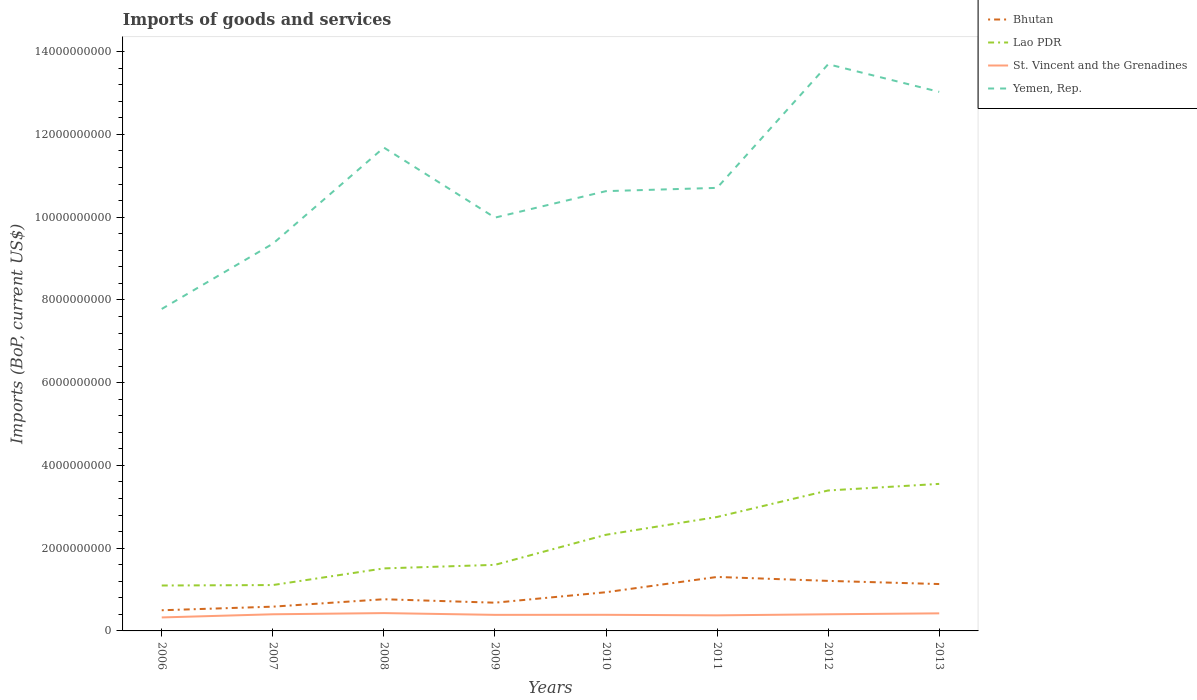How many different coloured lines are there?
Provide a short and direct response. 4. Does the line corresponding to Bhutan intersect with the line corresponding to Lao PDR?
Your response must be concise. No. Is the number of lines equal to the number of legend labels?
Your answer should be very brief. Yes. Across all years, what is the maximum amount spent on imports in St. Vincent and the Grenadines?
Give a very brief answer. 3.26e+08. In which year was the amount spent on imports in Lao PDR maximum?
Provide a succinct answer. 2006. What is the total amount spent on imports in Yemen, Rep. in the graph?
Your response must be concise. -2.01e+09. What is the difference between the highest and the second highest amount spent on imports in Yemen, Rep.?
Provide a short and direct response. 5.91e+09. What is the difference between the highest and the lowest amount spent on imports in Bhutan?
Make the answer very short. 4. Is the amount spent on imports in Bhutan strictly greater than the amount spent on imports in Yemen, Rep. over the years?
Your answer should be compact. Yes. How many lines are there?
Offer a very short reply. 4. Does the graph contain any zero values?
Make the answer very short. No. Where does the legend appear in the graph?
Your answer should be compact. Top right. How many legend labels are there?
Your answer should be compact. 4. What is the title of the graph?
Your answer should be very brief. Imports of goods and services. What is the label or title of the X-axis?
Provide a short and direct response. Years. What is the label or title of the Y-axis?
Provide a succinct answer. Imports (BoP, current US$). What is the Imports (BoP, current US$) in Bhutan in 2006?
Offer a very short reply. 4.99e+08. What is the Imports (BoP, current US$) in Lao PDR in 2006?
Keep it short and to the point. 1.10e+09. What is the Imports (BoP, current US$) in St. Vincent and the Grenadines in 2006?
Offer a terse response. 3.26e+08. What is the Imports (BoP, current US$) of Yemen, Rep. in 2006?
Give a very brief answer. 7.78e+09. What is the Imports (BoP, current US$) in Bhutan in 2007?
Your answer should be very brief. 5.86e+08. What is the Imports (BoP, current US$) in Lao PDR in 2007?
Provide a short and direct response. 1.11e+09. What is the Imports (BoP, current US$) of St. Vincent and the Grenadines in 2007?
Offer a terse response. 4.02e+08. What is the Imports (BoP, current US$) of Yemen, Rep. in 2007?
Provide a succinct answer. 9.36e+09. What is the Imports (BoP, current US$) in Bhutan in 2008?
Offer a terse response. 7.66e+08. What is the Imports (BoP, current US$) in Lao PDR in 2008?
Offer a terse response. 1.51e+09. What is the Imports (BoP, current US$) in St. Vincent and the Grenadines in 2008?
Your answer should be compact. 4.31e+08. What is the Imports (BoP, current US$) of Yemen, Rep. in 2008?
Keep it short and to the point. 1.17e+1. What is the Imports (BoP, current US$) of Bhutan in 2009?
Ensure brevity in your answer.  6.82e+08. What is the Imports (BoP, current US$) in Lao PDR in 2009?
Ensure brevity in your answer.  1.60e+09. What is the Imports (BoP, current US$) of St. Vincent and the Grenadines in 2009?
Make the answer very short. 3.88e+08. What is the Imports (BoP, current US$) in Yemen, Rep. in 2009?
Your answer should be compact. 9.99e+09. What is the Imports (BoP, current US$) in Bhutan in 2010?
Ensure brevity in your answer.  9.35e+08. What is the Imports (BoP, current US$) in Lao PDR in 2010?
Your answer should be very brief. 2.32e+09. What is the Imports (BoP, current US$) of St. Vincent and the Grenadines in 2010?
Your answer should be very brief. 3.89e+08. What is the Imports (BoP, current US$) in Yemen, Rep. in 2010?
Offer a terse response. 1.06e+1. What is the Imports (BoP, current US$) in Bhutan in 2011?
Your response must be concise. 1.30e+09. What is the Imports (BoP, current US$) in Lao PDR in 2011?
Provide a short and direct response. 2.75e+09. What is the Imports (BoP, current US$) of St. Vincent and the Grenadines in 2011?
Keep it short and to the point. 3.77e+08. What is the Imports (BoP, current US$) in Yemen, Rep. in 2011?
Your answer should be very brief. 1.07e+1. What is the Imports (BoP, current US$) of Bhutan in 2012?
Give a very brief answer. 1.21e+09. What is the Imports (BoP, current US$) in Lao PDR in 2012?
Offer a very short reply. 3.39e+09. What is the Imports (BoP, current US$) in St. Vincent and the Grenadines in 2012?
Ensure brevity in your answer.  4.02e+08. What is the Imports (BoP, current US$) of Yemen, Rep. in 2012?
Your answer should be very brief. 1.37e+1. What is the Imports (BoP, current US$) in Bhutan in 2013?
Provide a short and direct response. 1.13e+09. What is the Imports (BoP, current US$) of Lao PDR in 2013?
Keep it short and to the point. 3.55e+09. What is the Imports (BoP, current US$) in St. Vincent and the Grenadines in 2013?
Your answer should be very brief. 4.25e+08. What is the Imports (BoP, current US$) of Yemen, Rep. in 2013?
Offer a very short reply. 1.30e+1. Across all years, what is the maximum Imports (BoP, current US$) of Bhutan?
Keep it short and to the point. 1.30e+09. Across all years, what is the maximum Imports (BoP, current US$) of Lao PDR?
Ensure brevity in your answer.  3.55e+09. Across all years, what is the maximum Imports (BoP, current US$) of St. Vincent and the Grenadines?
Ensure brevity in your answer.  4.31e+08. Across all years, what is the maximum Imports (BoP, current US$) in Yemen, Rep.?
Your answer should be very brief. 1.37e+1. Across all years, what is the minimum Imports (BoP, current US$) of Bhutan?
Offer a very short reply. 4.99e+08. Across all years, what is the minimum Imports (BoP, current US$) of Lao PDR?
Make the answer very short. 1.10e+09. Across all years, what is the minimum Imports (BoP, current US$) of St. Vincent and the Grenadines?
Provide a succinct answer. 3.26e+08. Across all years, what is the minimum Imports (BoP, current US$) of Yemen, Rep.?
Make the answer very short. 7.78e+09. What is the total Imports (BoP, current US$) in Bhutan in the graph?
Your answer should be very brief. 7.12e+09. What is the total Imports (BoP, current US$) in Lao PDR in the graph?
Offer a terse response. 1.73e+1. What is the total Imports (BoP, current US$) of St. Vincent and the Grenadines in the graph?
Your response must be concise. 3.14e+09. What is the total Imports (BoP, current US$) of Yemen, Rep. in the graph?
Provide a succinct answer. 8.69e+1. What is the difference between the Imports (BoP, current US$) in Bhutan in 2006 and that in 2007?
Your response must be concise. -8.69e+07. What is the difference between the Imports (BoP, current US$) in Lao PDR in 2006 and that in 2007?
Your answer should be very brief. -1.08e+07. What is the difference between the Imports (BoP, current US$) of St. Vincent and the Grenadines in 2006 and that in 2007?
Make the answer very short. -7.63e+07. What is the difference between the Imports (BoP, current US$) of Yemen, Rep. in 2006 and that in 2007?
Your response must be concise. -1.58e+09. What is the difference between the Imports (BoP, current US$) of Bhutan in 2006 and that in 2008?
Ensure brevity in your answer.  -2.66e+08. What is the difference between the Imports (BoP, current US$) in Lao PDR in 2006 and that in 2008?
Your answer should be very brief. -4.13e+08. What is the difference between the Imports (BoP, current US$) of St. Vincent and the Grenadines in 2006 and that in 2008?
Keep it short and to the point. -1.05e+08. What is the difference between the Imports (BoP, current US$) in Yemen, Rep. in 2006 and that in 2008?
Keep it short and to the point. -3.90e+09. What is the difference between the Imports (BoP, current US$) of Bhutan in 2006 and that in 2009?
Ensure brevity in your answer.  -1.83e+08. What is the difference between the Imports (BoP, current US$) in Lao PDR in 2006 and that in 2009?
Provide a short and direct response. -4.99e+08. What is the difference between the Imports (BoP, current US$) in St. Vincent and the Grenadines in 2006 and that in 2009?
Make the answer very short. -6.22e+07. What is the difference between the Imports (BoP, current US$) in Yemen, Rep. in 2006 and that in 2009?
Provide a succinct answer. -2.21e+09. What is the difference between the Imports (BoP, current US$) of Bhutan in 2006 and that in 2010?
Your answer should be compact. -4.36e+08. What is the difference between the Imports (BoP, current US$) in Lao PDR in 2006 and that in 2010?
Provide a short and direct response. -1.23e+09. What is the difference between the Imports (BoP, current US$) in St. Vincent and the Grenadines in 2006 and that in 2010?
Provide a succinct answer. -6.33e+07. What is the difference between the Imports (BoP, current US$) in Yemen, Rep. in 2006 and that in 2010?
Provide a succinct answer. -2.85e+09. What is the difference between the Imports (BoP, current US$) of Bhutan in 2006 and that in 2011?
Offer a very short reply. -8.05e+08. What is the difference between the Imports (BoP, current US$) of Lao PDR in 2006 and that in 2011?
Provide a short and direct response. -1.66e+09. What is the difference between the Imports (BoP, current US$) of St. Vincent and the Grenadines in 2006 and that in 2011?
Your answer should be very brief. -5.08e+07. What is the difference between the Imports (BoP, current US$) in Yemen, Rep. in 2006 and that in 2011?
Your answer should be very brief. -2.93e+09. What is the difference between the Imports (BoP, current US$) in Bhutan in 2006 and that in 2012?
Keep it short and to the point. -7.10e+08. What is the difference between the Imports (BoP, current US$) in Lao PDR in 2006 and that in 2012?
Your answer should be compact. -2.30e+09. What is the difference between the Imports (BoP, current US$) of St. Vincent and the Grenadines in 2006 and that in 2012?
Ensure brevity in your answer.  -7.62e+07. What is the difference between the Imports (BoP, current US$) of Yemen, Rep. in 2006 and that in 2012?
Offer a very short reply. -5.91e+09. What is the difference between the Imports (BoP, current US$) in Bhutan in 2006 and that in 2013?
Your answer should be compact. -6.34e+08. What is the difference between the Imports (BoP, current US$) of Lao PDR in 2006 and that in 2013?
Your answer should be very brief. -2.46e+09. What is the difference between the Imports (BoP, current US$) in St. Vincent and the Grenadines in 2006 and that in 2013?
Your answer should be compact. -9.90e+07. What is the difference between the Imports (BoP, current US$) in Yemen, Rep. in 2006 and that in 2013?
Provide a succinct answer. -5.25e+09. What is the difference between the Imports (BoP, current US$) of Bhutan in 2007 and that in 2008?
Make the answer very short. -1.79e+08. What is the difference between the Imports (BoP, current US$) of Lao PDR in 2007 and that in 2008?
Your answer should be compact. -4.03e+08. What is the difference between the Imports (BoP, current US$) in St. Vincent and the Grenadines in 2007 and that in 2008?
Make the answer very short. -2.87e+07. What is the difference between the Imports (BoP, current US$) of Yemen, Rep. in 2007 and that in 2008?
Offer a very short reply. -2.32e+09. What is the difference between the Imports (BoP, current US$) in Bhutan in 2007 and that in 2009?
Give a very brief answer. -9.58e+07. What is the difference between the Imports (BoP, current US$) in Lao PDR in 2007 and that in 2009?
Offer a very short reply. -4.88e+08. What is the difference between the Imports (BoP, current US$) of St. Vincent and the Grenadines in 2007 and that in 2009?
Your answer should be very brief. 1.41e+07. What is the difference between the Imports (BoP, current US$) in Yemen, Rep. in 2007 and that in 2009?
Give a very brief answer. -6.31e+08. What is the difference between the Imports (BoP, current US$) in Bhutan in 2007 and that in 2010?
Your answer should be very brief. -3.49e+08. What is the difference between the Imports (BoP, current US$) in Lao PDR in 2007 and that in 2010?
Keep it short and to the point. -1.22e+09. What is the difference between the Imports (BoP, current US$) in St. Vincent and the Grenadines in 2007 and that in 2010?
Keep it short and to the point. 1.29e+07. What is the difference between the Imports (BoP, current US$) in Yemen, Rep. in 2007 and that in 2010?
Your answer should be compact. -1.27e+09. What is the difference between the Imports (BoP, current US$) in Bhutan in 2007 and that in 2011?
Make the answer very short. -7.18e+08. What is the difference between the Imports (BoP, current US$) of Lao PDR in 2007 and that in 2011?
Ensure brevity in your answer.  -1.65e+09. What is the difference between the Imports (BoP, current US$) in St. Vincent and the Grenadines in 2007 and that in 2011?
Your response must be concise. 2.55e+07. What is the difference between the Imports (BoP, current US$) of Yemen, Rep. in 2007 and that in 2011?
Ensure brevity in your answer.  -1.35e+09. What is the difference between the Imports (BoP, current US$) in Bhutan in 2007 and that in 2012?
Your response must be concise. -6.23e+08. What is the difference between the Imports (BoP, current US$) of Lao PDR in 2007 and that in 2012?
Give a very brief answer. -2.29e+09. What is the difference between the Imports (BoP, current US$) of St. Vincent and the Grenadines in 2007 and that in 2012?
Your answer should be compact. 1.83e+04. What is the difference between the Imports (BoP, current US$) in Yemen, Rep. in 2007 and that in 2012?
Offer a terse response. -4.34e+09. What is the difference between the Imports (BoP, current US$) of Bhutan in 2007 and that in 2013?
Offer a very short reply. -5.47e+08. What is the difference between the Imports (BoP, current US$) of Lao PDR in 2007 and that in 2013?
Provide a short and direct response. -2.44e+09. What is the difference between the Imports (BoP, current US$) in St. Vincent and the Grenadines in 2007 and that in 2013?
Keep it short and to the point. -2.27e+07. What is the difference between the Imports (BoP, current US$) of Yemen, Rep. in 2007 and that in 2013?
Keep it short and to the point. -3.67e+09. What is the difference between the Imports (BoP, current US$) in Bhutan in 2008 and that in 2009?
Provide a short and direct response. 8.35e+07. What is the difference between the Imports (BoP, current US$) of Lao PDR in 2008 and that in 2009?
Offer a very short reply. -8.56e+07. What is the difference between the Imports (BoP, current US$) in St. Vincent and the Grenadines in 2008 and that in 2009?
Provide a short and direct response. 4.28e+07. What is the difference between the Imports (BoP, current US$) of Yemen, Rep. in 2008 and that in 2009?
Provide a succinct answer. 1.69e+09. What is the difference between the Imports (BoP, current US$) of Bhutan in 2008 and that in 2010?
Give a very brief answer. -1.70e+08. What is the difference between the Imports (BoP, current US$) of Lao PDR in 2008 and that in 2010?
Your answer should be compact. -8.12e+08. What is the difference between the Imports (BoP, current US$) of St. Vincent and the Grenadines in 2008 and that in 2010?
Provide a succinct answer. 4.16e+07. What is the difference between the Imports (BoP, current US$) in Yemen, Rep. in 2008 and that in 2010?
Offer a terse response. 1.05e+09. What is the difference between the Imports (BoP, current US$) in Bhutan in 2008 and that in 2011?
Ensure brevity in your answer.  -5.39e+08. What is the difference between the Imports (BoP, current US$) in Lao PDR in 2008 and that in 2011?
Your answer should be compact. -1.24e+09. What is the difference between the Imports (BoP, current US$) in St. Vincent and the Grenadines in 2008 and that in 2011?
Your response must be concise. 5.42e+07. What is the difference between the Imports (BoP, current US$) of Yemen, Rep. in 2008 and that in 2011?
Give a very brief answer. 9.74e+08. What is the difference between the Imports (BoP, current US$) in Bhutan in 2008 and that in 2012?
Ensure brevity in your answer.  -4.44e+08. What is the difference between the Imports (BoP, current US$) in Lao PDR in 2008 and that in 2012?
Your answer should be very brief. -1.88e+09. What is the difference between the Imports (BoP, current US$) of St. Vincent and the Grenadines in 2008 and that in 2012?
Offer a very short reply. 2.87e+07. What is the difference between the Imports (BoP, current US$) in Yemen, Rep. in 2008 and that in 2012?
Your response must be concise. -2.01e+09. What is the difference between the Imports (BoP, current US$) in Bhutan in 2008 and that in 2013?
Provide a succinct answer. -3.67e+08. What is the difference between the Imports (BoP, current US$) in Lao PDR in 2008 and that in 2013?
Make the answer very short. -2.04e+09. What is the difference between the Imports (BoP, current US$) of St. Vincent and the Grenadines in 2008 and that in 2013?
Offer a very short reply. 6.00e+06. What is the difference between the Imports (BoP, current US$) of Yemen, Rep. in 2008 and that in 2013?
Provide a short and direct response. -1.35e+09. What is the difference between the Imports (BoP, current US$) of Bhutan in 2009 and that in 2010?
Your answer should be compact. -2.53e+08. What is the difference between the Imports (BoP, current US$) in Lao PDR in 2009 and that in 2010?
Provide a short and direct response. -7.27e+08. What is the difference between the Imports (BoP, current US$) of St. Vincent and the Grenadines in 2009 and that in 2010?
Give a very brief answer. -1.13e+06. What is the difference between the Imports (BoP, current US$) of Yemen, Rep. in 2009 and that in 2010?
Give a very brief answer. -6.41e+08. What is the difference between the Imports (BoP, current US$) of Bhutan in 2009 and that in 2011?
Give a very brief answer. -6.22e+08. What is the difference between the Imports (BoP, current US$) in Lao PDR in 2009 and that in 2011?
Your answer should be compact. -1.16e+09. What is the difference between the Imports (BoP, current US$) in St. Vincent and the Grenadines in 2009 and that in 2011?
Your answer should be very brief. 1.14e+07. What is the difference between the Imports (BoP, current US$) of Yemen, Rep. in 2009 and that in 2011?
Provide a short and direct response. -7.19e+08. What is the difference between the Imports (BoP, current US$) of Bhutan in 2009 and that in 2012?
Your answer should be compact. -5.27e+08. What is the difference between the Imports (BoP, current US$) of Lao PDR in 2009 and that in 2012?
Make the answer very short. -1.80e+09. What is the difference between the Imports (BoP, current US$) in St. Vincent and the Grenadines in 2009 and that in 2012?
Your response must be concise. -1.41e+07. What is the difference between the Imports (BoP, current US$) in Yemen, Rep. in 2009 and that in 2012?
Your response must be concise. -3.71e+09. What is the difference between the Imports (BoP, current US$) in Bhutan in 2009 and that in 2013?
Make the answer very short. -4.51e+08. What is the difference between the Imports (BoP, current US$) of Lao PDR in 2009 and that in 2013?
Keep it short and to the point. -1.96e+09. What is the difference between the Imports (BoP, current US$) of St. Vincent and the Grenadines in 2009 and that in 2013?
Your response must be concise. -3.68e+07. What is the difference between the Imports (BoP, current US$) in Yemen, Rep. in 2009 and that in 2013?
Offer a very short reply. -3.04e+09. What is the difference between the Imports (BoP, current US$) in Bhutan in 2010 and that in 2011?
Offer a very short reply. -3.69e+08. What is the difference between the Imports (BoP, current US$) in Lao PDR in 2010 and that in 2011?
Give a very brief answer. -4.30e+08. What is the difference between the Imports (BoP, current US$) in St. Vincent and the Grenadines in 2010 and that in 2011?
Your answer should be compact. 1.26e+07. What is the difference between the Imports (BoP, current US$) in Yemen, Rep. in 2010 and that in 2011?
Your answer should be very brief. -7.88e+07. What is the difference between the Imports (BoP, current US$) of Bhutan in 2010 and that in 2012?
Provide a short and direct response. -2.74e+08. What is the difference between the Imports (BoP, current US$) of Lao PDR in 2010 and that in 2012?
Your response must be concise. -1.07e+09. What is the difference between the Imports (BoP, current US$) of St. Vincent and the Grenadines in 2010 and that in 2012?
Provide a short and direct response. -1.29e+07. What is the difference between the Imports (BoP, current US$) in Yemen, Rep. in 2010 and that in 2012?
Ensure brevity in your answer.  -3.07e+09. What is the difference between the Imports (BoP, current US$) in Bhutan in 2010 and that in 2013?
Your answer should be compact. -1.98e+08. What is the difference between the Imports (BoP, current US$) of Lao PDR in 2010 and that in 2013?
Offer a very short reply. -1.23e+09. What is the difference between the Imports (BoP, current US$) of St. Vincent and the Grenadines in 2010 and that in 2013?
Make the answer very short. -3.56e+07. What is the difference between the Imports (BoP, current US$) in Yemen, Rep. in 2010 and that in 2013?
Your answer should be very brief. -2.40e+09. What is the difference between the Imports (BoP, current US$) of Bhutan in 2011 and that in 2012?
Give a very brief answer. 9.52e+07. What is the difference between the Imports (BoP, current US$) in Lao PDR in 2011 and that in 2012?
Keep it short and to the point. -6.41e+08. What is the difference between the Imports (BoP, current US$) in St. Vincent and the Grenadines in 2011 and that in 2012?
Provide a short and direct response. -2.55e+07. What is the difference between the Imports (BoP, current US$) in Yemen, Rep. in 2011 and that in 2012?
Provide a succinct answer. -2.99e+09. What is the difference between the Imports (BoP, current US$) in Bhutan in 2011 and that in 2013?
Make the answer very short. 1.72e+08. What is the difference between the Imports (BoP, current US$) in Lao PDR in 2011 and that in 2013?
Keep it short and to the point. -8.00e+08. What is the difference between the Imports (BoP, current US$) of St. Vincent and the Grenadines in 2011 and that in 2013?
Your answer should be very brief. -4.82e+07. What is the difference between the Imports (BoP, current US$) of Yemen, Rep. in 2011 and that in 2013?
Offer a very short reply. -2.32e+09. What is the difference between the Imports (BoP, current US$) in Bhutan in 2012 and that in 2013?
Ensure brevity in your answer.  7.64e+07. What is the difference between the Imports (BoP, current US$) in Lao PDR in 2012 and that in 2013?
Give a very brief answer. -1.59e+08. What is the difference between the Imports (BoP, current US$) of St. Vincent and the Grenadines in 2012 and that in 2013?
Keep it short and to the point. -2.27e+07. What is the difference between the Imports (BoP, current US$) in Yemen, Rep. in 2012 and that in 2013?
Keep it short and to the point. 6.68e+08. What is the difference between the Imports (BoP, current US$) in Bhutan in 2006 and the Imports (BoP, current US$) in Lao PDR in 2007?
Ensure brevity in your answer.  -6.09e+08. What is the difference between the Imports (BoP, current US$) of Bhutan in 2006 and the Imports (BoP, current US$) of St. Vincent and the Grenadines in 2007?
Offer a very short reply. 9.73e+07. What is the difference between the Imports (BoP, current US$) in Bhutan in 2006 and the Imports (BoP, current US$) in Yemen, Rep. in 2007?
Your response must be concise. -8.86e+09. What is the difference between the Imports (BoP, current US$) of Lao PDR in 2006 and the Imports (BoP, current US$) of St. Vincent and the Grenadines in 2007?
Offer a terse response. 6.96e+08. What is the difference between the Imports (BoP, current US$) of Lao PDR in 2006 and the Imports (BoP, current US$) of Yemen, Rep. in 2007?
Make the answer very short. -8.26e+09. What is the difference between the Imports (BoP, current US$) in St. Vincent and the Grenadines in 2006 and the Imports (BoP, current US$) in Yemen, Rep. in 2007?
Offer a very short reply. -9.03e+09. What is the difference between the Imports (BoP, current US$) of Bhutan in 2006 and the Imports (BoP, current US$) of Lao PDR in 2008?
Make the answer very short. -1.01e+09. What is the difference between the Imports (BoP, current US$) in Bhutan in 2006 and the Imports (BoP, current US$) in St. Vincent and the Grenadines in 2008?
Give a very brief answer. 6.86e+07. What is the difference between the Imports (BoP, current US$) of Bhutan in 2006 and the Imports (BoP, current US$) of Yemen, Rep. in 2008?
Keep it short and to the point. -1.12e+1. What is the difference between the Imports (BoP, current US$) in Lao PDR in 2006 and the Imports (BoP, current US$) in St. Vincent and the Grenadines in 2008?
Offer a very short reply. 6.67e+08. What is the difference between the Imports (BoP, current US$) of Lao PDR in 2006 and the Imports (BoP, current US$) of Yemen, Rep. in 2008?
Provide a succinct answer. -1.06e+1. What is the difference between the Imports (BoP, current US$) in St. Vincent and the Grenadines in 2006 and the Imports (BoP, current US$) in Yemen, Rep. in 2008?
Offer a terse response. -1.14e+1. What is the difference between the Imports (BoP, current US$) of Bhutan in 2006 and the Imports (BoP, current US$) of Lao PDR in 2009?
Provide a succinct answer. -1.10e+09. What is the difference between the Imports (BoP, current US$) of Bhutan in 2006 and the Imports (BoP, current US$) of St. Vincent and the Grenadines in 2009?
Your response must be concise. 1.11e+08. What is the difference between the Imports (BoP, current US$) in Bhutan in 2006 and the Imports (BoP, current US$) in Yemen, Rep. in 2009?
Keep it short and to the point. -9.49e+09. What is the difference between the Imports (BoP, current US$) of Lao PDR in 2006 and the Imports (BoP, current US$) of St. Vincent and the Grenadines in 2009?
Offer a very short reply. 7.10e+08. What is the difference between the Imports (BoP, current US$) in Lao PDR in 2006 and the Imports (BoP, current US$) in Yemen, Rep. in 2009?
Provide a succinct answer. -8.89e+09. What is the difference between the Imports (BoP, current US$) in St. Vincent and the Grenadines in 2006 and the Imports (BoP, current US$) in Yemen, Rep. in 2009?
Make the answer very short. -9.66e+09. What is the difference between the Imports (BoP, current US$) in Bhutan in 2006 and the Imports (BoP, current US$) in Lao PDR in 2010?
Make the answer very short. -1.82e+09. What is the difference between the Imports (BoP, current US$) of Bhutan in 2006 and the Imports (BoP, current US$) of St. Vincent and the Grenadines in 2010?
Ensure brevity in your answer.  1.10e+08. What is the difference between the Imports (BoP, current US$) in Bhutan in 2006 and the Imports (BoP, current US$) in Yemen, Rep. in 2010?
Make the answer very short. -1.01e+1. What is the difference between the Imports (BoP, current US$) in Lao PDR in 2006 and the Imports (BoP, current US$) in St. Vincent and the Grenadines in 2010?
Give a very brief answer. 7.08e+08. What is the difference between the Imports (BoP, current US$) of Lao PDR in 2006 and the Imports (BoP, current US$) of Yemen, Rep. in 2010?
Ensure brevity in your answer.  -9.53e+09. What is the difference between the Imports (BoP, current US$) of St. Vincent and the Grenadines in 2006 and the Imports (BoP, current US$) of Yemen, Rep. in 2010?
Provide a succinct answer. -1.03e+1. What is the difference between the Imports (BoP, current US$) in Bhutan in 2006 and the Imports (BoP, current US$) in Lao PDR in 2011?
Offer a very short reply. -2.25e+09. What is the difference between the Imports (BoP, current US$) of Bhutan in 2006 and the Imports (BoP, current US$) of St. Vincent and the Grenadines in 2011?
Your answer should be compact. 1.23e+08. What is the difference between the Imports (BoP, current US$) of Bhutan in 2006 and the Imports (BoP, current US$) of Yemen, Rep. in 2011?
Offer a terse response. -1.02e+1. What is the difference between the Imports (BoP, current US$) in Lao PDR in 2006 and the Imports (BoP, current US$) in St. Vincent and the Grenadines in 2011?
Keep it short and to the point. 7.21e+08. What is the difference between the Imports (BoP, current US$) in Lao PDR in 2006 and the Imports (BoP, current US$) in Yemen, Rep. in 2011?
Ensure brevity in your answer.  -9.61e+09. What is the difference between the Imports (BoP, current US$) in St. Vincent and the Grenadines in 2006 and the Imports (BoP, current US$) in Yemen, Rep. in 2011?
Keep it short and to the point. -1.04e+1. What is the difference between the Imports (BoP, current US$) of Bhutan in 2006 and the Imports (BoP, current US$) of Lao PDR in 2012?
Make the answer very short. -2.89e+09. What is the difference between the Imports (BoP, current US$) of Bhutan in 2006 and the Imports (BoP, current US$) of St. Vincent and the Grenadines in 2012?
Give a very brief answer. 9.73e+07. What is the difference between the Imports (BoP, current US$) of Bhutan in 2006 and the Imports (BoP, current US$) of Yemen, Rep. in 2012?
Provide a succinct answer. -1.32e+1. What is the difference between the Imports (BoP, current US$) in Lao PDR in 2006 and the Imports (BoP, current US$) in St. Vincent and the Grenadines in 2012?
Offer a terse response. 6.96e+08. What is the difference between the Imports (BoP, current US$) of Lao PDR in 2006 and the Imports (BoP, current US$) of Yemen, Rep. in 2012?
Your response must be concise. -1.26e+1. What is the difference between the Imports (BoP, current US$) of St. Vincent and the Grenadines in 2006 and the Imports (BoP, current US$) of Yemen, Rep. in 2012?
Make the answer very short. -1.34e+1. What is the difference between the Imports (BoP, current US$) of Bhutan in 2006 and the Imports (BoP, current US$) of Lao PDR in 2013?
Your answer should be compact. -3.05e+09. What is the difference between the Imports (BoP, current US$) in Bhutan in 2006 and the Imports (BoP, current US$) in St. Vincent and the Grenadines in 2013?
Keep it short and to the point. 7.46e+07. What is the difference between the Imports (BoP, current US$) of Bhutan in 2006 and the Imports (BoP, current US$) of Yemen, Rep. in 2013?
Make the answer very short. -1.25e+1. What is the difference between the Imports (BoP, current US$) in Lao PDR in 2006 and the Imports (BoP, current US$) in St. Vincent and the Grenadines in 2013?
Keep it short and to the point. 6.73e+08. What is the difference between the Imports (BoP, current US$) of Lao PDR in 2006 and the Imports (BoP, current US$) of Yemen, Rep. in 2013?
Provide a succinct answer. -1.19e+1. What is the difference between the Imports (BoP, current US$) of St. Vincent and the Grenadines in 2006 and the Imports (BoP, current US$) of Yemen, Rep. in 2013?
Provide a succinct answer. -1.27e+1. What is the difference between the Imports (BoP, current US$) of Bhutan in 2007 and the Imports (BoP, current US$) of Lao PDR in 2008?
Provide a succinct answer. -9.25e+08. What is the difference between the Imports (BoP, current US$) in Bhutan in 2007 and the Imports (BoP, current US$) in St. Vincent and the Grenadines in 2008?
Offer a very short reply. 1.56e+08. What is the difference between the Imports (BoP, current US$) of Bhutan in 2007 and the Imports (BoP, current US$) of Yemen, Rep. in 2008?
Offer a very short reply. -1.11e+1. What is the difference between the Imports (BoP, current US$) in Lao PDR in 2007 and the Imports (BoP, current US$) in St. Vincent and the Grenadines in 2008?
Your response must be concise. 6.78e+08. What is the difference between the Imports (BoP, current US$) of Lao PDR in 2007 and the Imports (BoP, current US$) of Yemen, Rep. in 2008?
Provide a succinct answer. -1.06e+1. What is the difference between the Imports (BoP, current US$) of St. Vincent and the Grenadines in 2007 and the Imports (BoP, current US$) of Yemen, Rep. in 2008?
Your answer should be compact. -1.13e+1. What is the difference between the Imports (BoP, current US$) in Bhutan in 2007 and the Imports (BoP, current US$) in Lao PDR in 2009?
Your response must be concise. -1.01e+09. What is the difference between the Imports (BoP, current US$) in Bhutan in 2007 and the Imports (BoP, current US$) in St. Vincent and the Grenadines in 2009?
Offer a terse response. 1.98e+08. What is the difference between the Imports (BoP, current US$) of Bhutan in 2007 and the Imports (BoP, current US$) of Yemen, Rep. in 2009?
Make the answer very short. -9.40e+09. What is the difference between the Imports (BoP, current US$) of Lao PDR in 2007 and the Imports (BoP, current US$) of St. Vincent and the Grenadines in 2009?
Offer a terse response. 7.20e+08. What is the difference between the Imports (BoP, current US$) of Lao PDR in 2007 and the Imports (BoP, current US$) of Yemen, Rep. in 2009?
Your answer should be compact. -8.88e+09. What is the difference between the Imports (BoP, current US$) of St. Vincent and the Grenadines in 2007 and the Imports (BoP, current US$) of Yemen, Rep. in 2009?
Provide a succinct answer. -9.59e+09. What is the difference between the Imports (BoP, current US$) of Bhutan in 2007 and the Imports (BoP, current US$) of Lao PDR in 2010?
Provide a short and direct response. -1.74e+09. What is the difference between the Imports (BoP, current US$) in Bhutan in 2007 and the Imports (BoP, current US$) in St. Vincent and the Grenadines in 2010?
Ensure brevity in your answer.  1.97e+08. What is the difference between the Imports (BoP, current US$) of Bhutan in 2007 and the Imports (BoP, current US$) of Yemen, Rep. in 2010?
Offer a very short reply. -1.00e+1. What is the difference between the Imports (BoP, current US$) in Lao PDR in 2007 and the Imports (BoP, current US$) in St. Vincent and the Grenadines in 2010?
Ensure brevity in your answer.  7.19e+08. What is the difference between the Imports (BoP, current US$) of Lao PDR in 2007 and the Imports (BoP, current US$) of Yemen, Rep. in 2010?
Your answer should be very brief. -9.52e+09. What is the difference between the Imports (BoP, current US$) in St. Vincent and the Grenadines in 2007 and the Imports (BoP, current US$) in Yemen, Rep. in 2010?
Your answer should be very brief. -1.02e+1. What is the difference between the Imports (BoP, current US$) of Bhutan in 2007 and the Imports (BoP, current US$) of Lao PDR in 2011?
Provide a succinct answer. -2.17e+09. What is the difference between the Imports (BoP, current US$) in Bhutan in 2007 and the Imports (BoP, current US$) in St. Vincent and the Grenadines in 2011?
Your answer should be compact. 2.10e+08. What is the difference between the Imports (BoP, current US$) of Bhutan in 2007 and the Imports (BoP, current US$) of Yemen, Rep. in 2011?
Your answer should be compact. -1.01e+1. What is the difference between the Imports (BoP, current US$) of Lao PDR in 2007 and the Imports (BoP, current US$) of St. Vincent and the Grenadines in 2011?
Provide a short and direct response. 7.32e+08. What is the difference between the Imports (BoP, current US$) of Lao PDR in 2007 and the Imports (BoP, current US$) of Yemen, Rep. in 2011?
Ensure brevity in your answer.  -9.60e+09. What is the difference between the Imports (BoP, current US$) of St. Vincent and the Grenadines in 2007 and the Imports (BoP, current US$) of Yemen, Rep. in 2011?
Keep it short and to the point. -1.03e+1. What is the difference between the Imports (BoP, current US$) in Bhutan in 2007 and the Imports (BoP, current US$) in Lao PDR in 2012?
Offer a terse response. -2.81e+09. What is the difference between the Imports (BoP, current US$) in Bhutan in 2007 and the Imports (BoP, current US$) in St. Vincent and the Grenadines in 2012?
Make the answer very short. 1.84e+08. What is the difference between the Imports (BoP, current US$) of Bhutan in 2007 and the Imports (BoP, current US$) of Yemen, Rep. in 2012?
Give a very brief answer. -1.31e+1. What is the difference between the Imports (BoP, current US$) of Lao PDR in 2007 and the Imports (BoP, current US$) of St. Vincent and the Grenadines in 2012?
Offer a very short reply. 7.06e+08. What is the difference between the Imports (BoP, current US$) of Lao PDR in 2007 and the Imports (BoP, current US$) of Yemen, Rep. in 2012?
Your answer should be compact. -1.26e+1. What is the difference between the Imports (BoP, current US$) of St. Vincent and the Grenadines in 2007 and the Imports (BoP, current US$) of Yemen, Rep. in 2012?
Offer a terse response. -1.33e+1. What is the difference between the Imports (BoP, current US$) in Bhutan in 2007 and the Imports (BoP, current US$) in Lao PDR in 2013?
Your response must be concise. -2.97e+09. What is the difference between the Imports (BoP, current US$) of Bhutan in 2007 and the Imports (BoP, current US$) of St. Vincent and the Grenadines in 2013?
Ensure brevity in your answer.  1.62e+08. What is the difference between the Imports (BoP, current US$) in Bhutan in 2007 and the Imports (BoP, current US$) in Yemen, Rep. in 2013?
Give a very brief answer. -1.24e+1. What is the difference between the Imports (BoP, current US$) of Lao PDR in 2007 and the Imports (BoP, current US$) of St. Vincent and the Grenadines in 2013?
Provide a short and direct response. 6.84e+08. What is the difference between the Imports (BoP, current US$) of Lao PDR in 2007 and the Imports (BoP, current US$) of Yemen, Rep. in 2013?
Offer a terse response. -1.19e+1. What is the difference between the Imports (BoP, current US$) in St. Vincent and the Grenadines in 2007 and the Imports (BoP, current US$) in Yemen, Rep. in 2013?
Ensure brevity in your answer.  -1.26e+1. What is the difference between the Imports (BoP, current US$) of Bhutan in 2008 and the Imports (BoP, current US$) of Lao PDR in 2009?
Provide a succinct answer. -8.31e+08. What is the difference between the Imports (BoP, current US$) of Bhutan in 2008 and the Imports (BoP, current US$) of St. Vincent and the Grenadines in 2009?
Keep it short and to the point. 3.78e+08. What is the difference between the Imports (BoP, current US$) of Bhutan in 2008 and the Imports (BoP, current US$) of Yemen, Rep. in 2009?
Offer a very short reply. -9.22e+09. What is the difference between the Imports (BoP, current US$) in Lao PDR in 2008 and the Imports (BoP, current US$) in St. Vincent and the Grenadines in 2009?
Offer a very short reply. 1.12e+09. What is the difference between the Imports (BoP, current US$) in Lao PDR in 2008 and the Imports (BoP, current US$) in Yemen, Rep. in 2009?
Give a very brief answer. -8.48e+09. What is the difference between the Imports (BoP, current US$) in St. Vincent and the Grenadines in 2008 and the Imports (BoP, current US$) in Yemen, Rep. in 2009?
Offer a very short reply. -9.56e+09. What is the difference between the Imports (BoP, current US$) in Bhutan in 2008 and the Imports (BoP, current US$) in Lao PDR in 2010?
Offer a very short reply. -1.56e+09. What is the difference between the Imports (BoP, current US$) in Bhutan in 2008 and the Imports (BoP, current US$) in St. Vincent and the Grenadines in 2010?
Make the answer very short. 3.76e+08. What is the difference between the Imports (BoP, current US$) in Bhutan in 2008 and the Imports (BoP, current US$) in Yemen, Rep. in 2010?
Provide a short and direct response. -9.86e+09. What is the difference between the Imports (BoP, current US$) in Lao PDR in 2008 and the Imports (BoP, current US$) in St. Vincent and the Grenadines in 2010?
Your answer should be very brief. 1.12e+09. What is the difference between the Imports (BoP, current US$) in Lao PDR in 2008 and the Imports (BoP, current US$) in Yemen, Rep. in 2010?
Ensure brevity in your answer.  -9.12e+09. What is the difference between the Imports (BoP, current US$) of St. Vincent and the Grenadines in 2008 and the Imports (BoP, current US$) of Yemen, Rep. in 2010?
Your answer should be compact. -1.02e+1. What is the difference between the Imports (BoP, current US$) in Bhutan in 2008 and the Imports (BoP, current US$) in Lao PDR in 2011?
Your response must be concise. -1.99e+09. What is the difference between the Imports (BoP, current US$) in Bhutan in 2008 and the Imports (BoP, current US$) in St. Vincent and the Grenadines in 2011?
Keep it short and to the point. 3.89e+08. What is the difference between the Imports (BoP, current US$) in Bhutan in 2008 and the Imports (BoP, current US$) in Yemen, Rep. in 2011?
Offer a very short reply. -9.94e+09. What is the difference between the Imports (BoP, current US$) of Lao PDR in 2008 and the Imports (BoP, current US$) of St. Vincent and the Grenadines in 2011?
Your answer should be very brief. 1.13e+09. What is the difference between the Imports (BoP, current US$) of Lao PDR in 2008 and the Imports (BoP, current US$) of Yemen, Rep. in 2011?
Give a very brief answer. -9.20e+09. What is the difference between the Imports (BoP, current US$) in St. Vincent and the Grenadines in 2008 and the Imports (BoP, current US$) in Yemen, Rep. in 2011?
Keep it short and to the point. -1.03e+1. What is the difference between the Imports (BoP, current US$) in Bhutan in 2008 and the Imports (BoP, current US$) in Lao PDR in 2012?
Give a very brief answer. -2.63e+09. What is the difference between the Imports (BoP, current US$) in Bhutan in 2008 and the Imports (BoP, current US$) in St. Vincent and the Grenadines in 2012?
Provide a short and direct response. 3.64e+08. What is the difference between the Imports (BoP, current US$) in Bhutan in 2008 and the Imports (BoP, current US$) in Yemen, Rep. in 2012?
Make the answer very short. -1.29e+1. What is the difference between the Imports (BoP, current US$) in Lao PDR in 2008 and the Imports (BoP, current US$) in St. Vincent and the Grenadines in 2012?
Offer a very short reply. 1.11e+09. What is the difference between the Imports (BoP, current US$) in Lao PDR in 2008 and the Imports (BoP, current US$) in Yemen, Rep. in 2012?
Give a very brief answer. -1.22e+1. What is the difference between the Imports (BoP, current US$) of St. Vincent and the Grenadines in 2008 and the Imports (BoP, current US$) of Yemen, Rep. in 2012?
Give a very brief answer. -1.33e+1. What is the difference between the Imports (BoP, current US$) in Bhutan in 2008 and the Imports (BoP, current US$) in Lao PDR in 2013?
Give a very brief answer. -2.79e+09. What is the difference between the Imports (BoP, current US$) in Bhutan in 2008 and the Imports (BoP, current US$) in St. Vincent and the Grenadines in 2013?
Give a very brief answer. 3.41e+08. What is the difference between the Imports (BoP, current US$) in Bhutan in 2008 and the Imports (BoP, current US$) in Yemen, Rep. in 2013?
Keep it short and to the point. -1.23e+1. What is the difference between the Imports (BoP, current US$) of Lao PDR in 2008 and the Imports (BoP, current US$) of St. Vincent and the Grenadines in 2013?
Your response must be concise. 1.09e+09. What is the difference between the Imports (BoP, current US$) of Lao PDR in 2008 and the Imports (BoP, current US$) of Yemen, Rep. in 2013?
Offer a terse response. -1.15e+1. What is the difference between the Imports (BoP, current US$) of St. Vincent and the Grenadines in 2008 and the Imports (BoP, current US$) of Yemen, Rep. in 2013?
Provide a succinct answer. -1.26e+1. What is the difference between the Imports (BoP, current US$) of Bhutan in 2009 and the Imports (BoP, current US$) of Lao PDR in 2010?
Make the answer very short. -1.64e+09. What is the difference between the Imports (BoP, current US$) of Bhutan in 2009 and the Imports (BoP, current US$) of St. Vincent and the Grenadines in 2010?
Your answer should be very brief. 2.93e+08. What is the difference between the Imports (BoP, current US$) of Bhutan in 2009 and the Imports (BoP, current US$) of Yemen, Rep. in 2010?
Your response must be concise. -9.95e+09. What is the difference between the Imports (BoP, current US$) of Lao PDR in 2009 and the Imports (BoP, current US$) of St. Vincent and the Grenadines in 2010?
Offer a very short reply. 1.21e+09. What is the difference between the Imports (BoP, current US$) of Lao PDR in 2009 and the Imports (BoP, current US$) of Yemen, Rep. in 2010?
Provide a short and direct response. -9.03e+09. What is the difference between the Imports (BoP, current US$) of St. Vincent and the Grenadines in 2009 and the Imports (BoP, current US$) of Yemen, Rep. in 2010?
Give a very brief answer. -1.02e+1. What is the difference between the Imports (BoP, current US$) of Bhutan in 2009 and the Imports (BoP, current US$) of Lao PDR in 2011?
Provide a succinct answer. -2.07e+09. What is the difference between the Imports (BoP, current US$) of Bhutan in 2009 and the Imports (BoP, current US$) of St. Vincent and the Grenadines in 2011?
Provide a short and direct response. 3.06e+08. What is the difference between the Imports (BoP, current US$) in Bhutan in 2009 and the Imports (BoP, current US$) in Yemen, Rep. in 2011?
Provide a succinct answer. -1.00e+1. What is the difference between the Imports (BoP, current US$) in Lao PDR in 2009 and the Imports (BoP, current US$) in St. Vincent and the Grenadines in 2011?
Provide a short and direct response. 1.22e+09. What is the difference between the Imports (BoP, current US$) in Lao PDR in 2009 and the Imports (BoP, current US$) in Yemen, Rep. in 2011?
Offer a terse response. -9.11e+09. What is the difference between the Imports (BoP, current US$) of St. Vincent and the Grenadines in 2009 and the Imports (BoP, current US$) of Yemen, Rep. in 2011?
Provide a succinct answer. -1.03e+1. What is the difference between the Imports (BoP, current US$) of Bhutan in 2009 and the Imports (BoP, current US$) of Lao PDR in 2012?
Ensure brevity in your answer.  -2.71e+09. What is the difference between the Imports (BoP, current US$) of Bhutan in 2009 and the Imports (BoP, current US$) of St. Vincent and the Grenadines in 2012?
Offer a very short reply. 2.80e+08. What is the difference between the Imports (BoP, current US$) of Bhutan in 2009 and the Imports (BoP, current US$) of Yemen, Rep. in 2012?
Ensure brevity in your answer.  -1.30e+1. What is the difference between the Imports (BoP, current US$) in Lao PDR in 2009 and the Imports (BoP, current US$) in St. Vincent and the Grenadines in 2012?
Keep it short and to the point. 1.19e+09. What is the difference between the Imports (BoP, current US$) in Lao PDR in 2009 and the Imports (BoP, current US$) in Yemen, Rep. in 2012?
Ensure brevity in your answer.  -1.21e+1. What is the difference between the Imports (BoP, current US$) of St. Vincent and the Grenadines in 2009 and the Imports (BoP, current US$) of Yemen, Rep. in 2012?
Keep it short and to the point. -1.33e+1. What is the difference between the Imports (BoP, current US$) of Bhutan in 2009 and the Imports (BoP, current US$) of Lao PDR in 2013?
Offer a very short reply. -2.87e+09. What is the difference between the Imports (BoP, current US$) of Bhutan in 2009 and the Imports (BoP, current US$) of St. Vincent and the Grenadines in 2013?
Provide a succinct answer. 2.57e+08. What is the difference between the Imports (BoP, current US$) in Bhutan in 2009 and the Imports (BoP, current US$) in Yemen, Rep. in 2013?
Your response must be concise. -1.23e+1. What is the difference between the Imports (BoP, current US$) of Lao PDR in 2009 and the Imports (BoP, current US$) of St. Vincent and the Grenadines in 2013?
Your answer should be compact. 1.17e+09. What is the difference between the Imports (BoP, current US$) of Lao PDR in 2009 and the Imports (BoP, current US$) of Yemen, Rep. in 2013?
Your answer should be very brief. -1.14e+1. What is the difference between the Imports (BoP, current US$) in St. Vincent and the Grenadines in 2009 and the Imports (BoP, current US$) in Yemen, Rep. in 2013?
Offer a terse response. -1.26e+1. What is the difference between the Imports (BoP, current US$) of Bhutan in 2010 and the Imports (BoP, current US$) of Lao PDR in 2011?
Your answer should be very brief. -1.82e+09. What is the difference between the Imports (BoP, current US$) of Bhutan in 2010 and the Imports (BoP, current US$) of St. Vincent and the Grenadines in 2011?
Provide a succinct answer. 5.59e+08. What is the difference between the Imports (BoP, current US$) of Bhutan in 2010 and the Imports (BoP, current US$) of Yemen, Rep. in 2011?
Provide a short and direct response. -9.77e+09. What is the difference between the Imports (BoP, current US$) in Lao PDR in 2010 and the Imports (BoP, current US$) in St. Vincent and the Grenadines in 2011?
Your answer should be very brief. 1.95e+09. What is the difference between the Imports (BoP, current US$) of Lao PDR in 2010 and the Imports (BoP, current US$) of Yemen, Rep. in 2011?
Your response must be concise. -8.38e+09. What is the difference between the Imports (BoP, current US$) in St. Vincent and the Grenadines in 2010 and the Imports (BoP, current US$) in Yemen, Rep. in 2011?
Your answer should be compact. -1.03e+1. What is the difference between the Imports (BoP, current US$) of Bhutan in 2010 and the Imports (BoP, current US$) of Lao PDR in 2012?
Give a very brief answer. -2.46e+09. What is the difference between the Imports (BoP, current US$) in Bhutan in 2010 and the Imports (BoP, current US$) in St. Vincent and the Grenadines in 2012?
Your answer should be compact. 5.33e+08. What is the difference between the Imports (BoP, current US$) of Bhutan in 2010 and the Imports (BoP, current US$) of Yemen, Rep. in 2012?
Offer a very short reply. -1.28e+1. What is the difference between the Imports (BoP, current US$) in Lao PDR in 2010 and the Imports (BoP, current US$) in St. Vincent and the Grenadines in 2012?
Offer a very short reply. 1.92e+09. What is the difference between the Imports (BoP, current US$) in Lao PDR in 2010 and the Imports (BoP, current US$) in Yemen, Rep. in 2012?
Provide a short and direct response. -1.14e+1. What is the difference between the Imports (BoP, current US$) of St. Vincent and the Grenadines in 2010 and the Imports (BoP, current US$) of Yemen, Rep. in 2012?
Your response must be concise. -1.33e+1. What is the difference between the Imports (BoP, current US$) of Bhutan in 2010 and the Imports (BoP, current US$) of Lao PDR in 2013?
Give a very brief answer. -2.62e+09. What is the difference between the Imports (BoP, current US$) in Bhutan in 2010 and the Imports (BoP, current US$) in St. Vincent and the Grenadines in 2013?
Make the answer very short. 5.10e+08. What is the difference between the Imports (BoP, current US$) in Bhutan in 2010 and the Imports (BoP, current US$) in Yemen, Rep. in 2013?
Provide a succinct answer. -1.21e+1. What is the difference between the Imports (BoP, current US$) of Lao PDR in 2010 and the Imports (BoP, current US$) of St. Vincent and the Grenadines in 2013?
Keep it short and to the point. 1.90e+09. What is the difference between the Imports (BoP, current US$) in Lao PDR in 2010 and the Imports (BoP, current US$) in Yemen, Rep. in 2013?
Make the answer very short. -1.07e+1. What is the difference between the Imports (BoP, current US$) in St. Vincent and the Grenadines in 2010 and the Imports (BoP, current US$) in Yemen, Rep. in 2013?
Your answer should be very brief. -1.26e+1. What is the difference between the Imports (BoP, current US$) in Bhutan in 2011 and the Imports (BoP, current US$) in Lao PDR in 2012?
Give a very brief answer. -2.09e+09. What is the difference between the Imports (BoP, current US$) in Bhutan in 2011 and the Imports (BoP, current US$) in St. Vincent and the Grenadines in 2012?
Ensure brevity in your answer.  9.02e+08. What is the difference between the Imports (BoP, current US$) of Bhutan in 2011 and the Imports (BoP, current US$) of Yemen, Rep. in 2012?
Offer a terse response. -1.24e+1. What is the difference between the Imports (BoP, current US$) in Lao PDR in 2011 and the Imports (BoP, current US$) in St. Vincent and the Grenadines in 2012?
Offer a very short reply. 2.35e+09. What is the difference between the Imports (BoP, current US$) of Lao PDR in 2011 and the Imports (BoP, current US$) of Yemen, Rep. in 2012?
Give a very brief answer. -1.09e+1. What is the difference between the Imports (BoP, current US$) in St. Vincent and the Grenadines in 2011 and the Imports (BoP, current US$) in Yemen, Rep. in 2012?
Offer a terse response. -1.33e+1. What is the difference between the Imports (BoP, current US$) of Bhutan in 2011 and the Imports (BoP, current US$) of Lao PDR in 2013?
Your response must be concise. -2.25e+09. What is the difference between the Imports (BoP, current US$) of Bhutan in 2011 and the Imports (BoP, current US$) of St. Vincent and the Grenadines in 2013?
Your answer should be compact. 8.80e+08. What is the difference between the Imports (BoP, current US$) in Bhutan in 2011 and the Imports (BoP, current US$) in Yemen, Rep. in 2013?
Give a very brief answer. -1.17e+1. What is the difference between the Imports (BoP, current US$) of Lao PDR in 2011 and the Imports (BoP, current US$) of St. Vincent and the Grenadines in 2013?
Make the answer very short. 2.33e+09. What is the difference between the Imports (BoP, current US$) of Lao PDR in 2011 and the Imports (BoP, current US$) of Yemen, Rep. in 2013?
Keep it short and to the point. -1.03e+1. What is the difference between the Imports (BoP, current US$) in St. Vincent and the Grenadines in 2011 and the Imports (BoP, current US$) in Yemen, Rep. in 2013?
Ensure brevity in your answer.  -1.27e+1. What is the difference between the Imports (BoP, current US$) of Bhutan in 2012 and the Imports (BoP, current US$) of Lao PDR in 2013?
Keep it short and to the point. -2.34e+09. What is the difference between the Imports (BoP, current US$) in Bhutan in 2012 and the Imports (BoP, current US$) in St. Vincent and the Grenadines in 2013?
Make the answer very short. 7.85e+08. What is the difference between the Imports (BoP, current US$) of Bhutan in 2012 and the Imports (BoP, current US$) of Yemen, Rep. in 2013?
Your answer should be compact. -1.18e+1. What is the difference between the Imports (BoP, current US$) of Lao PDR in 2012 and the Imports (BoP, current US$) of St. Vincent and the Grenadines in 2013?
Keep it short and to the point. 2.97e+09. What is the difference between the Imports (BoP, current US$) in Lao PDR in 2012 and the Imports (BoP, current US$) in Yemen, Rep. in 2013?
Provide a succinct answer. -9.63e+09. What is the difference between the Imports (BoP, current US$) in St. Vincent and the Grenadines in 2012 and the Imports (BoP, current US$) in Yemen, Rep. in 2013?
Offer a very short reply. -1.26e+1. What is the average Imports (BoP, current US$) of Bhutan per year?
Keep it short and to the point. 8.89e+08. What is the average Imports (BoP, current US$) in Lao PDR per year?
Make the answer very short. 2.17e+09. What is the average Imports (BoP, current US$) in St. Vincent and the Grenadines per year?
Provide a short and direct response. 3.92e+08. What is the average Imports (BoP, current US$) in Yemen, Rep. per year?
Your answer should be very brief. 1.09e+1. In the year 2006, what is the difference between the Imports (BoP, current US$) in Bhutan and Imports (BoP, current US$) in Lao PDR?
Provide a short and direct response. -5.98e+08. In the year 2006, what is the difference between the Imports (BoP, current US$) of Bhutan and Imports (BoP, current US$) of St. Vincent and the Grenadines?
Your answer should be compact. 1.74e+08. In the year 2006, what is the difference between the Imports (BoP, current US$) in Bhutan and Imports (BoP, current US$) in Yemen, Rep.?
Keep it short and to the point. -7.28e+09. In the year 2006, what is the difference between the Imports (BoP, current US$) of Lao PDR and Imports (BoP, current US$) of St. Vincent and the Grenadines?
Provide a short and direct response. 7.72e+08. In the year 2006, what is the difference between the Imports (BoP, current US$) of Lao PDR and Imports (BoP, current US$) of Yemen, Rep.?
Offer a very short reply. -6.68e+09. In the year 2006, what is the difference between the Imports (BoP, current US$) in St. Vincent and the Grenadines and Imports (BoP, current US$) in Yemen, Rep.?
Give a very brief answer. -7.46e+09. In the year 2007, what is the difference between the Imports (BoP, current US$) of Bhutan and Imports (BoP, current US$) of Lao PDR?
Offer a terse response. -5.22e+08. In the year 2007, what is the difference between the Imports (BoP, current US$) of Bhutan and Imports (BoP, current US$) of St. Vincent and the Grenadines?
Ensure brevity in your answer.  1.84e+08. In the year 2007, what is the difference between the Imports (BoP, current US$) in Bhutan and Imports (BoP, current US$) in Yemen, Rep.?
Offer a very short reply. -8.77e+09. In the year 2007, what is the difference between the Imports (BoP, current US$) in Lao PDR and Imports (BoP, current US$) in St. Vincent and the Grenadines?
Your response must be concise. 7.06e+08. In the year 2007, what is the difference between the Imports (BoP, current US$) in Lao PDR and Imports (BoP, current US$) in Yemen, Rep.?
Your answer should be compact. -8.25e+09. In the year 2007, what is the difference between the Imports (BoP, current US$) of St. Vincent and the Grenadines and Imports (BoP, current US$) of Yemen, Rep.?
Your answer should be compact. -8.96e+09. In the year 2008, what is the difference between the Imports (BoP, current US$) in Bhutan and Imports (BoP, current US$) in Lao PDR?
Provide a succinct answer. -7.45e+08. In the year 2008, what is the difference between the Imports (BoP, current US$) of Bhutan and Imports (BoP, current US$) of St. Vincent and the Grenadines?
Give a very brief answer. 3.35e+08. In the year 2008, what is the difference between the Imports (BoP, current US$) of Bhutan and Imports (BoP, current US$) of Yemen, Rep.?
Make the answer very short. -1.09e+1. In the year 2008, what is the difference between the Imports (BoP, current US$) in Lao PDR and Imports (BoP, current US$) in St. Vincent and the Grenadines?
Provide a succinct answer. 1.08e+09. In the year 2008, what is the difference between the Imports (BoP, current US$) of Lao PDR and Imports (BoP, current US$) of Yemen, Rep.?
Provide a succinct answer. -1.02e+1. In the year 2008, what is the difference between the Imports (BoP, current US$) of St. Vincent and the Grenadines and Imports (BoP, current US$) of Yemen, Rep.?
Provide a succinct answer. -1.13e+1. In the year 2009, what is the difference between the Imports (BoP, current US$) of Bhutan and Imports (BoP, current US$) of Lao PDR?
Keep it short and to the point. -9.15e+08. In the year 2009, what is the difference between the Imports (BoP, current US$) of Bhutan and Imports (BoP, current US$) of St. Vincent and the Grenadines?
Make the answer very short. 2.94e+08. In the year 2009, what is the difference between the Imports (BoP, current US$) of Bhutan and Imports (BoP, current US$) of Yemen, Rep.?
Give a very brief answer. -9.31e+09. In the year 2009, what is the difference between the Imports (BoP, current US$) in Lao PDR and Imports (BoP, current US$) in St. Vincent and the Grenadines?
Give a very brief answer. 1.21e+09. In the year 2009, what is the difference between the Imports (BoP, current US$) of Lao PDR and Imports (BoP, current US$) of Yemen, Rep.?
Your answer should be compact. -8.39e+09. In the year 2009, what is the difference between the Imports (BoP, current US$) of St. Vincent and the Grenadines and Imports (BoP, current US$) of Yemen, Rep.?
Your response must be concise. -9.60e+09. In the year 2010, what is the difference between the Imports (BoP, current US$) of Bhutan and Imports (BoP, current US$) of Lao PDR?
Offer a terse response. -1.39e+09. In the year 2010, what is the difference between the Imports (BoP, current US$) in Bhutan and Imports (BoP, current US$) in St. Vincent and the Grenadines?
Your answer should be very brief. 5.46e+08. In the year 2010, what is the difference between the Imports (BoP, current US$) of Bhutan and Imports (BoP, current US$) of Yemen, Rep.?
Your answer should be compact. -9.69e+09. In the year 2010, what is the difference between the Imports (BoP, current US$) of Lao PDR and Imports (BoP, current US$) of St. Vincent and the Grenadines?
Provide a succinct answer. 1.93e+09. In the year 2010, what is the difference between the Imports (BoP, current US$) in Lao PDR and Imports (BoP, current US$) in Yemen, Rep.?
Ensure brevity in your answer.  -8.31e+09. In the year 2010, what is the difference between the Imports (BoP, current US$) in St. Vincent and the Grenadines and Imports (BoP, current US$) in Yemen, Rep.?
Offer a very short reply. -1.02e+1. In the year 2011, what is the difference between the Imports (BoP, current US$) in Bhutan and Imports (BoP, current US$) in Lao PDR?
Ensure brevity in your answer.  -1.45e+09. In the year 2011, what is the difference between the Imports (BoP, current US$) in Bhutan and Imports (BoP, current US$) in St. Vincent and the Grenadines?
Offer a very short reply. 9.28e+08. In the year 2011, what is the difference between the Imports (BoP, current US$) of Bhutan and Imports (BoP, current US$) of Yemen, Rep.?
Your response must be concise. -9.40e+09. In the year 2011, what is the difference between the Imports (BoP, current US$) in Lao PDR and Imports (BoP, current US$) in St. Vincent and the Grenadines?
Give a very brief answer. 2.38e+09. In the year 2011, what is the difference between the Imports (BoP, current US$) of Lao PDR and Imports (BoP, current US$) of Yemen, Rep.?
Give a very brief answer. -7.95e+09. In the year 2011, what is the difference between the Imports (BoP, current US$) of St. Vincent and the Grenadines and Imports (BoP, current US$) of Yemen, Rep.?
Ensure brevity in your answer.  -1.03e+1. In the year 2012, what is the difference between the Imports (BoP, current US$) in Bhutan and Imports (BoP, current US$) in Lao PDR?
Your response must be concise. -2.19e+09. In the year 2012, what is the difference between the Imports (BoP, current US$) of Bhutan and Imports (BoP, current US$) of St. Vincent and the Grenadines?
Offer a very short reply. 8.07e+08. In the year 2012, what is the difference between the Imports (BoP, current US$) of Bhutan and Imports (BoP, current US$) of Yemen, Rep.?
Your answer should be very brief. -1.25e+1. In the year 2012, what is the difference between the Imports (BoP, current US$) in Lao PDR and Imports (BoP, current US$) in St. Vincent and the Grenadines?
Your answer should be compact. 2.99e+09. In the year 2012, what is the difference between the Imports (BoP, current US$) of Lao PDR and Imports (BoP, current US$) of Yemen, Rep.?
Make the answer very short. -1.03e+1. In the year 2012, what is the difference between the Imports (BoP, current US$) of St. Vincent and the Grenadines and Imports (BoP, current US$) of Yemen, Rep.?
Provide a short and direct response. -1.33e+1. In the year 2013, what is the difference between the Imports (BoP, current US$) in Bhutan and Imports (BoP, current US$) in Lao PDR?
Your response must be concise. -2.42e+09. In the year 2013, what is the difference between the Imports (BoP, current US$) of Bhutan and Imports (BoP, current US$) of St. Vincent and the Grenadines?
Offer a terse response. 7.08e+08. In the year 2013, what is the difference between the Imports (BoP, current US$) of Bhutan and Imports (BoP, current US$) of Yemen, Rep.?
Give a very brief answer. -1.19e+1. In the year 2013, what is the difference between the Imports (BoP, current US$) of Lao PDR and Imports (BoP, current US$) of St. Vincent and the Grenadines?
Your response must be concise. 3.13e+09. In the year 2013, what is the difference between the Imports (BoP, current US$) of Lao PDR and Imports (BoP, current US$) of Yemen, Rep.?
Your answer should be compact. -9.47e+09. In the year 2013, what is the difference between the Imports (BoP, current US$) in St. Vincent and the Grenadines and Imports (BoP, current US$) in Yemen, Rep.?
Ensure brevity in your answer.  -1.26e+1. What is the ratio of the Imports (BoP, current US$) in Bhutan in 2006 to that in 2007?
Keep it short and to the point. 0.85. What is the ratio of the Imports (BoP, current US$) of Lao PDR in 2006 to that in 2007?
Make the answer very short. 0.99. What is the ratio of the Imports (BoP, current US$) of St. Vincent and the Grenadines in 2006 to that in 2007?
Keep it short and to the point. 0.81. What is the ratio of the Imports (BoP, current US$) in Yemen, Rep. in 2006 to that in 2007?
Give a very brief answer. 0.83. What is the ratio of the Imports (BoP, current US$) in Bhutan in 2006 to that in 2008?
Your answer should be very brief. 0.65. What is the ratio of the Imports (BoP, current US$) in Lao PDR in 2006 to that in 2008?
Your answer should be very brief. 0.73. What is the ratio of the Imports (BoP, current US$) in St. Vincent and the Grenadines in 2006 to that in 2008?
Provide a succinct answer. 0.76. What is the ratio of the Imports (BoP, current US$) in Yemen, Rep. in 2006 to that in 2008?
Ensure brevity in your answer.  0.67. What is the ratio of the Imports (BoP, current US$) in Bhutan in 2006 to that in 2009?
Offer a very short reply. 0.73. What is the ratio of the Imports (BoP, current US$) of Lao PDR in 2006 to that in 2009?
Provide a succinct answer. 0.69. What is the ratio of the Imports (BoP, current US$) of St. Vincent and the Grenadines in 2006 to that in 2009?
Give a very brief answer. 0.84. What is the ratio of the Imports (BoP, current US$) of Yemen, Rep. in 2006 to that in 2009?
Give a very brief answer. 0.78. What is the ratio of the Imports (BoP, current US$) in Bhutan in 2006 to that in 2010?
Your response must be concise. 0.53. What is the ratio of the Imports (BoP, current US$) of Lao PDR in 2006 to that in 2010?
Your answer should be very brief. 0.47. What is the ratio of the Imports (BoP, current US$) of St. Vincent and the Grenadines in 2006 to that in 2010?
Give a very brief answer. 0.84. What is the ratio of the Imports (BoP, current US$) of Yemen, Rep. in 2006 to that in 2010?
Give a very brief answer. 0.73. What is the ratio of the Imports (BoP, current US$) in Bhutan in 2006 to that in 2011?
Your answer should be compact. 0.38. What is the ratio of the Imports (BoP, current US$) of Lao PDR in 2006 to that in 2011?
Your answer should be very brief. 0.4. What is the ratio of the Imports (BoP, current US$) of St. Vincent and the Grenadines in 2006 to that in 2011?
Your answer should be compact. 0.87. What is the ratio of the Imports (BoP, current US$) of Yemen, Rep. in 2006 to that in 2011?
Ensure brevity in your answer.  0.73. What is the ratio of the Imports (BoP, current US$) of Bhutan in 2006 to that in 2012?
Give a very brief answer. 0.41. What is the ratio of the Imports (BoP, current US$) in Lao PDR in 2006 to that in 2012?
Your answer should be very brief. 0.32. What is the ratio of the Imports (BoP, current US$) of St. Vincent and the Grenadines in 2006 to that in 2012?
Make the answer very short. 0.81. What is the ratio of the Imports (BoP, current US$) in Yemen, Rep. in 2006 to that in 2012?
Keep it short and to the point. 0.57. What is the ratio of the Imports (BoP, current US$) of Bhutan in 2006 to that in 2013?
Ensure brevity in your answer.  0.44. What is the ratio of the Imports (BoP, current US$) in Lao PDR in 2006 to that in 2013?
Provide a short and direct response. 0.31. What is the ratio of the Imports (BoP, current US$) in St. Vincent and the Grenadines in 2006 to that in 2013?
Your answer should be very brief. 0.77. What is the ratio of the Imports (BoP, current US$) in Yemen, Rep. in 2006 to that in 2013?
Offer a terse response. 0.6. What is the ratio of the Imports (BoP, current US$) of Bhutan in 2007 to that in 2008?
Offer a terse response. 0.77. What is the ratio of the Imports (BoP, current US$) of Lao PDR in 2007 to that in 2008?
Give a very brief answer. 0.73. What is the ratio of the Imports (BoP, current US$) in St. Vincent and the Grenadines in 2007 to that in 2008?
Keep it short and to the point. 0.93. What is the ratio of the Imports (BoP, current US$) of Yemen, Rep. in 2007 to that in 2008?
Give a very brief answer. 0.8. What is the ratio of the Imports (BoP, current US$) in Bhutan in 2007 to that in 2009?
Provide a short and direct response. 0.86. What is the ratio of the Imports (BoP, current US$) in Lao PDR in 2007 to that in 2009?
Make the answer very short. 0.69. What is the ratio of the Imports (BoP, current US$) in St. Vincent and the Grenadines in 2007 to that in 2009?
Make the answer very short. 1.04. What is the ratio of the Imports (BoP, current US$) in Yemen, Rep. in 2007 to that in 2009?
Provide a succinct answer. 0.94. What is the ratio of the Imports (BoP, current US$) of Bhutan in 2007 to that in 2010?
Provide a succinct answer. 0.63. What is the ratio of the Imports (BoP, current US$) of Lao PDR in 2007 to that in 2010?
Make the answer very short. 0.48. What is the ratio of the Imports (BoP, current US$) in St. Vincent and the Grenadines in 2007 to that in 2010?
Keep it short and to the point. 1.03. What is the ratio of the Imports (BoP, current US$) of Yemen, Rep. in 2007 to that in 2010?
Offer a terse response. 0.88. What is the ratio of the Imports (BoP, current US$) in Bhutan in 2007 to that in 2011?
Your answer should be very brief. 0.45. What is the ratio of the Imports (BoP, current US$) in Lao PDR in 2007 to that in 2011?
Offer a very short reply. 0.4. What is the ratio of the Imports (BoP, current US$) of St. Vincent and the Grenadines in 2007 to that in 2011?
Offer a very short reply. 1.07. What is the ratio of the Imports (BoP, current US$) in Yemen, Rep. in 2007 to that in 2011?
Offer a terse response. 0.87. What is the ratio of the Imports (BoP, current US$) in Bhutan in 2007 to that in 2012?
Keep it short and to the point. 0.48. What is the ratio of the Imports (BoP, current US$) in Lao PDR in 2007 to that in 2012?
Offer a very short reply. 0.33. What is the ratio of the Imports (BoP, current US$) of St. Vincent and the Grenadines in 2007 to that in 2012?
Offer a very short reply. 1. What is the ratio of the Imports (BoP, current US$) in Yemen, Rep. in 2007 to that in 2012?
Your response must be concise. 0.68. What is the ratio of the Imports (BoP, current US$) of Bhutan in 2007 to that in 2013?
Give a very brief answer. 0.52. What is the ratio of the Imports (BoP, current US$) of Lao PDR in 2007 to that in 2013?
Offer a terse response. 0.31. What is the ratio of the Imports (BoP, current US$) in St. Vincent and the Grenadines in 2007 to that in 2013?
Provide a short and direct response. 0.95. What is the ratio of the Imports (BoP, current US$) of Yemen, Rep. in 2007 to that in 2013?
Offer a very short reply. 0.72. What is the ratio of the Imports (BoP, current US$) of Bhutan in 2008 to that in 2009?
Provide a succinct answer. 1.12. What is the ratio of the Imports (BoP, current US$) of Lao PDR in 2008 to that in 2009?
Give a very brief answer. 0.95. What is the ratio of the Imports (BoP, current US$) of St. Vincent and the Grenadines in 2008 to that in 2009?
Ensure brevity in your answer.  1.11. What is the ratio of the Imports (BoP, current US$) in Yemen, Rep. in 2008 to that in 2009?
Keep it short and to the point. 1.17. What is the ratio of the Imports (BoP, current US$) in Bhutan in 2008 to that in 2010?
Offer a terse response. 0.82. What is the ratio of the Imports (BoP, current US$) in Lao PDR in 2008 to that in 2010?
Offer a very short reply. 0.65. What is the ratio of the Imports (BoP, current US$) of St. Vincent and the Grenadines in 2008 to that in 2010?
Make the answer very short. 1.11. What is the ratio of the Imports (BoP, current US$) of Yemen, Rep. in 2008 to that in 2010?
Your answer should be very brief. 1.1. What is the ratio of the Imports (BoP, current US$) of Bhutan in 2008 to that in 2011?
Provide a short and direct response. 0.59. What is the ratio of the Imports (BoP, current US$) in Lao PDR in 2008 to that in 2011?
Give a very brief answer. 0.55. What is the ratio of the Imports (BoP, current US$) in St. Vincent and the Grenadines in 2008 to that in 2011?
Provide a short and direct response. 1.14. What is the ratio of the Imports (BoP, current US$) of Bhutan in 2008 to that in 2012?
Your response must be concise. 0.63. What is the ratio of the Imports (BoP, current US$) of Lao PDR in 2008 to that in 2012?
Your response must be concise. 0.45. What is the ratio of the Imports (BoP, current US$) in St. Vincent and the Grenadines in 2008 to that in 2012?
Give a very brief answer. 1.07. What is the ratio of the Imports (BoP, current US$) of Yemen, Rep. in 2008 to that in 2012?
Give a very brief answer. 0.85. What is the ratio of the Imports (BoP, current US$) in Bhutan in 2008 to that in 2013?
Provide a short and direct response. 0.68. What is the ratio of the Imports (BoP, current US$) in Lao PDR in 2008 to that in 2013?
Keep it short and to the point. 0.43. What is the ratio of the Imports (BoP, current US$) in St. Vincent and the Grenadines in 2008 to that in 2013?
Your response must be concise. 1.01. What is the ratio of the Imports (BoP, current US$) in Yemen, Rep. in 2008 to that in 2013?
Give a very brief answer. 0.9. What is the ratio of the Imports (BoP, current US$) in Bhutan in 2009 to that in 2010?
Give a very brief answer. 0.73. What is the ratio of the Imports (BoP, current US$) of Lao PDR in 2009 to that in 2010?
Give a very brief answer. 0.69. What is the ratio of the Imports (BoP, current US$) in Yemen, Rep. in 2009 to that in 2010?
Offer a terse response. 0.94. What is the ratio of the Imports (BoP, current US$) of Bhutan in 2009 to that in 2011?
Offer a terse response. 0.52. What is the ratio of the Imports (BoP, current US$) in Lao PDR in 2009 to that in 2011?
Provide a succinct answer. 0.58. What is the ratio of the Imports (BoP, current US$) of St. Vincent and the Grenadines in 2009 to that in 2011?
Your answer should be very brief. 1.03. What is the ratio of the Imports (BoP, current US$) in Yemen, Rep. in 2009 to that in 2011?
Make the answer very short. 0.93. What is the ratio of the Imports (BoP, current US$) of Bhutan in 2009 to that in 2012?
Offer a terse response. 0.56. What is the ratio of the Imports (BoP, current US$) in Lao PDR in 2009 to that in 2012?
Offer a very short reply. 0.47. What is the ratio of the Imports (BoP, current US$) in St. Vincent and the Grenadines in 2009 to that in 2012?
Provide a short and direct response. 0.96. What is the ratio of the Imports (BoP, current US$) in Yemen, Rep. in 2009 to that in 2012?
Offer a terse response. 0.73. What is the ratio of the Imports (BoP, current US$) of Bhutan in 2009 to that in 2013?
Keep it short and to the point. 0.6. What is the ratio of the Imports (BoP, current US$) of Lao PDR in 2009 to that in 2013?
Offer a terse response. 0.45. What is the ratio of the Imports (BoP, current US$) in St. Vincent and the Grenadines in 2009 to that in 2013?
Keep it short and to the point. 0.91. What is the ratio of the Imports (BoP, current US$) in Yemen, Rep. in 2009 to that in 2013?
Ensure brevity in your answer.  0.77. What is the ratio of the Imports (BoP, current US$) in Bhutan in 2010 to that in 2011?
Ensure brevity in your answer.  0.72. What is the ratio of the Imports (BoP, current US$) in Lao PDR in 2010 to that in 2011?
Offer a very short reply. 0.84. What is the ratio of the Imports (BoP, current US$) in Bhutan in 2010 to that in 2012?
Your answer should be very brief. 0.77. What is the ratio of the Imports (BoP, current US$) of Lao PDR in 2010 to that in 2012?
Provide a short and direct response. 0.68. What is the ratio of the Imports (BoP, current US$) in St. Vincent and the Grenadines in 2010 to that in 2012?
Your answer should be very brief. 0.97. What is the ratio of the Imports (BoP, current US$) in Yemen, Rep. in 2010 to that in 2012?
Provide a short and direct response. 0.78. What is the ratio of the Imports (BoP, current US$) in Bhutan in 2010 to that in 2013?
Provide a short and direct response. 0.83. What is the ratio of the Imports (BoP, current US$) of Lao PDR in 2010 to that in 2013?
Your answer should be very brief. 0.65. What is the ratio of the Imports (BoP, current US$) in St. Vincent and the Grenadines in 2010 to that in 2013?
Ensure brevity in your answer.  0.92. What is the ratio of the Imports (BoP, current US$) of Yemen, Rep. in 2010 to that in 2013?
Give a very brief answer. 0.82. What is the ratio of the Imports (BoP, current US$) of Bhutan in 2011 to that in 2012?
Provide a short and direct response. 1.08. What is the ratio of the Imports (BoP, current US$) in Lao PDR in 2011 to that in 2012?
Your answer should be compact. 0.81. What is the ratio of the Imports (BoP, current US$) in St. Vincent and the Grenadines in 2011 to that in 2012?
Ensure brevity in your answer.  0.94. What is the ratio of the Imports (BoP, current US$) in Yemen, Rep. in 2011 to that in 2012?
Provide a short and direct response. 0.78. What is the ratio of the Imports (BoP, current US$) in Bhutan in 2011 to that in 2013?
Ensure brevity in your answer.  1.15. What is the ratio of the Imports (BoP, current US$) in Lao PDR in 2011 to that in 2013?
Offer a terse response. 0.77. What is the ratio of the Imports (BoP, current US$) in St. Vincent and the Grenadines in 2011 to that in 2013?
Make the answer very short. 0.89. What is the ratio of the Imports (BoP, current US$) of Yemen, Rep. in 2011 to that in 2013?
Offer a terse response. 0.82. What is the ratio of the Imports (BoP, current US$) in Bhutan in 2012 to that in 2013?
Your answer should be very brief. 1.07. What is the ratio of the Imports (BoP, current US$) in Lao PDR in 2012 to that in 2013?
Your response must be concise. 0.96. What is the ratio of the Imports (BoP, current US$) of St. Vincent and the Grenadines in 2012 to that in 2013?
Keep it short and to the point. 0.95. What is the ratio of the Imports (BoP, current US$) in Yemen, Rep. in 2012 to that in 2013?
Offer a very short reply. 1.05. What is the difference between the highest and the second highest Imports (BoP, current US$) of Bhutan?
Your answer should be compact. 9.52e+07. What is the difference between the highest and the second highest Imports (BoP, current US$) of Lao PDR?
Provide a succinct answer. 1.59e+08. What is the difference between the highest and the second highest Imports (BoP, current US$) of St. Vincent and the Grenadines?
Your response must be concise. 6.00e+06. What is the difference between the highest and the second highest Imports (BoP, current US$) in Yemen, Rep.?
Offer a terse response. 6.68e+08. What is the difference between the highest and the lowest Imports (BoP, current US$) in Bhutan?
Your answer should be very brief. 8.05e+08. What is the difference between the highest and the lowest Imports (BoP, current US$) of Lao PDR?
Keep it short and to the point. 2.46e+09. What is the difference between the highest and the lowest Imports (BoP, current US$) of St. Vincent and the Grenadines?
Offer a terse response. 1.05e+08. What is the difference between the highest and the lowest Imports (BoP, current US$) in Yemen, Rep.?
Offer a very short reply. 5.91e+09. 